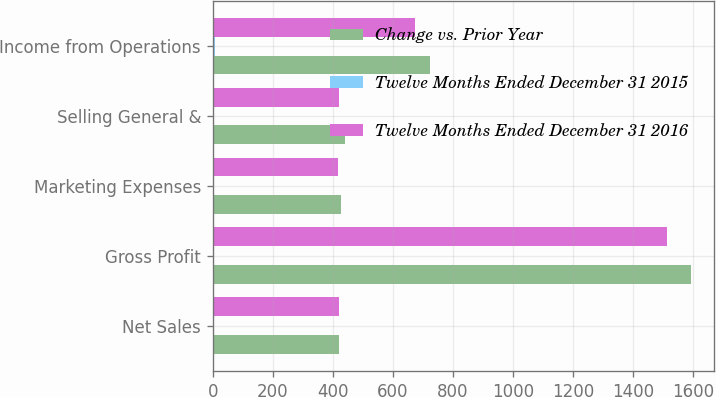<chart> <loc_0><loc_0><loc_500><loc_500><stacked_bar_chart><ecel><fcel>Net Sales<fcel>Gross Profit<fcel>Marketing Expenses<fcel>Selling General &<fcel>Income from Operations<nl><fcel>Change vs. Prior Year<fcel>420.1<fcel>1590.6<fcel>427.2<fcel>439.2<fcel>724.2<nl><fcel>Twelve Months Ended December 31 2015<fcel>2.9<fcel>5.2<fcel>2.3<fcel>4.5<fcel>7.4<nl><fcel>Twelve Months Ended December 31 2016<fcel>420.1<fcel>1511.8<fcel>417.5<fcel>420.1<fcel>674.2<nl></chart> 